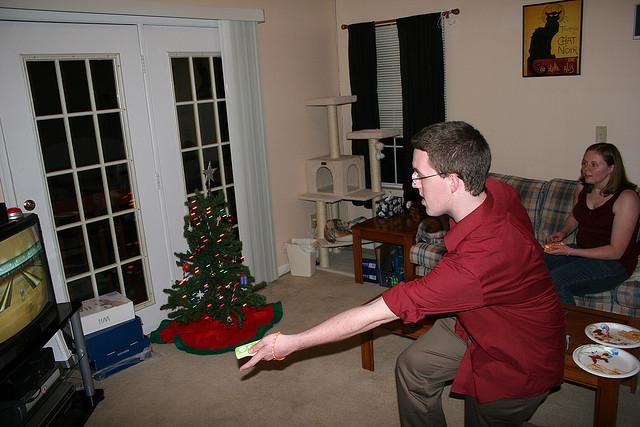What kind of game is the man playing? bowling 